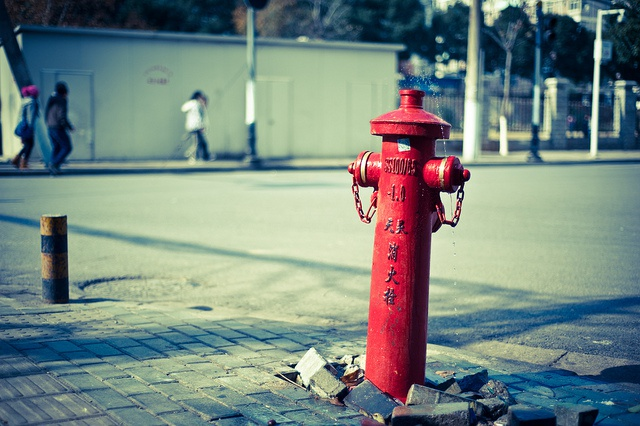Describe the objects in this image and their specific colors. I can see fire hydrant in black, salmon, maroon, and brown tones, people in black, navy, blue, and gray tones, people in black, darkgray, beige, teal, and blue tones, people in black, navy, and blue tones, and backpack in black, navy, and blue tones in this image. 